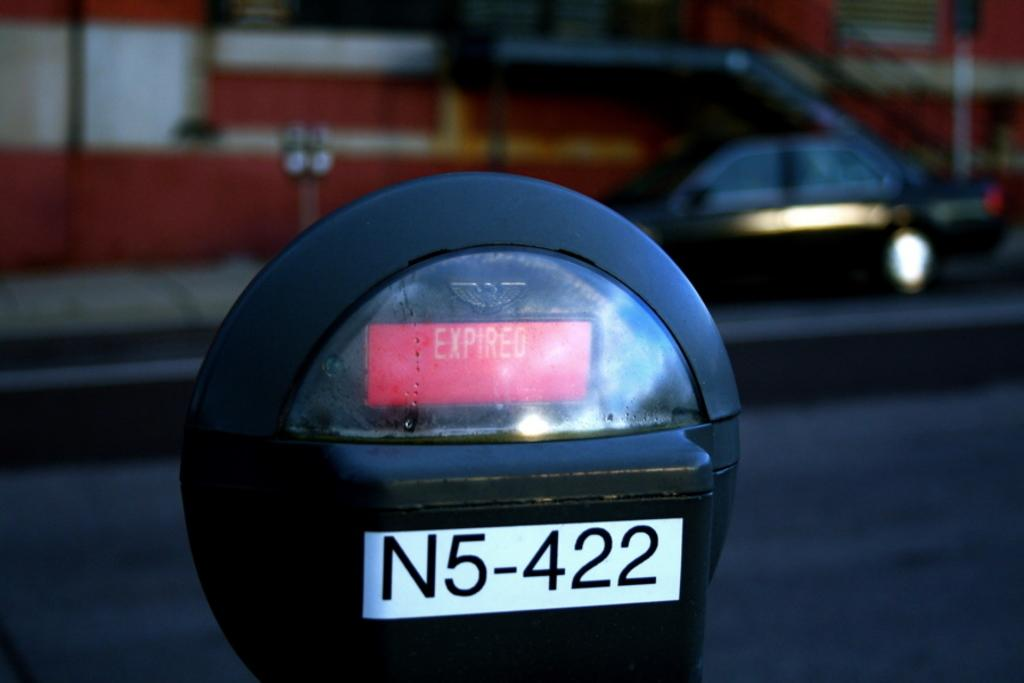<image>
Present a compact description of the photo's key features. An expired parking meter that has a sticker with an identifying number on it. 